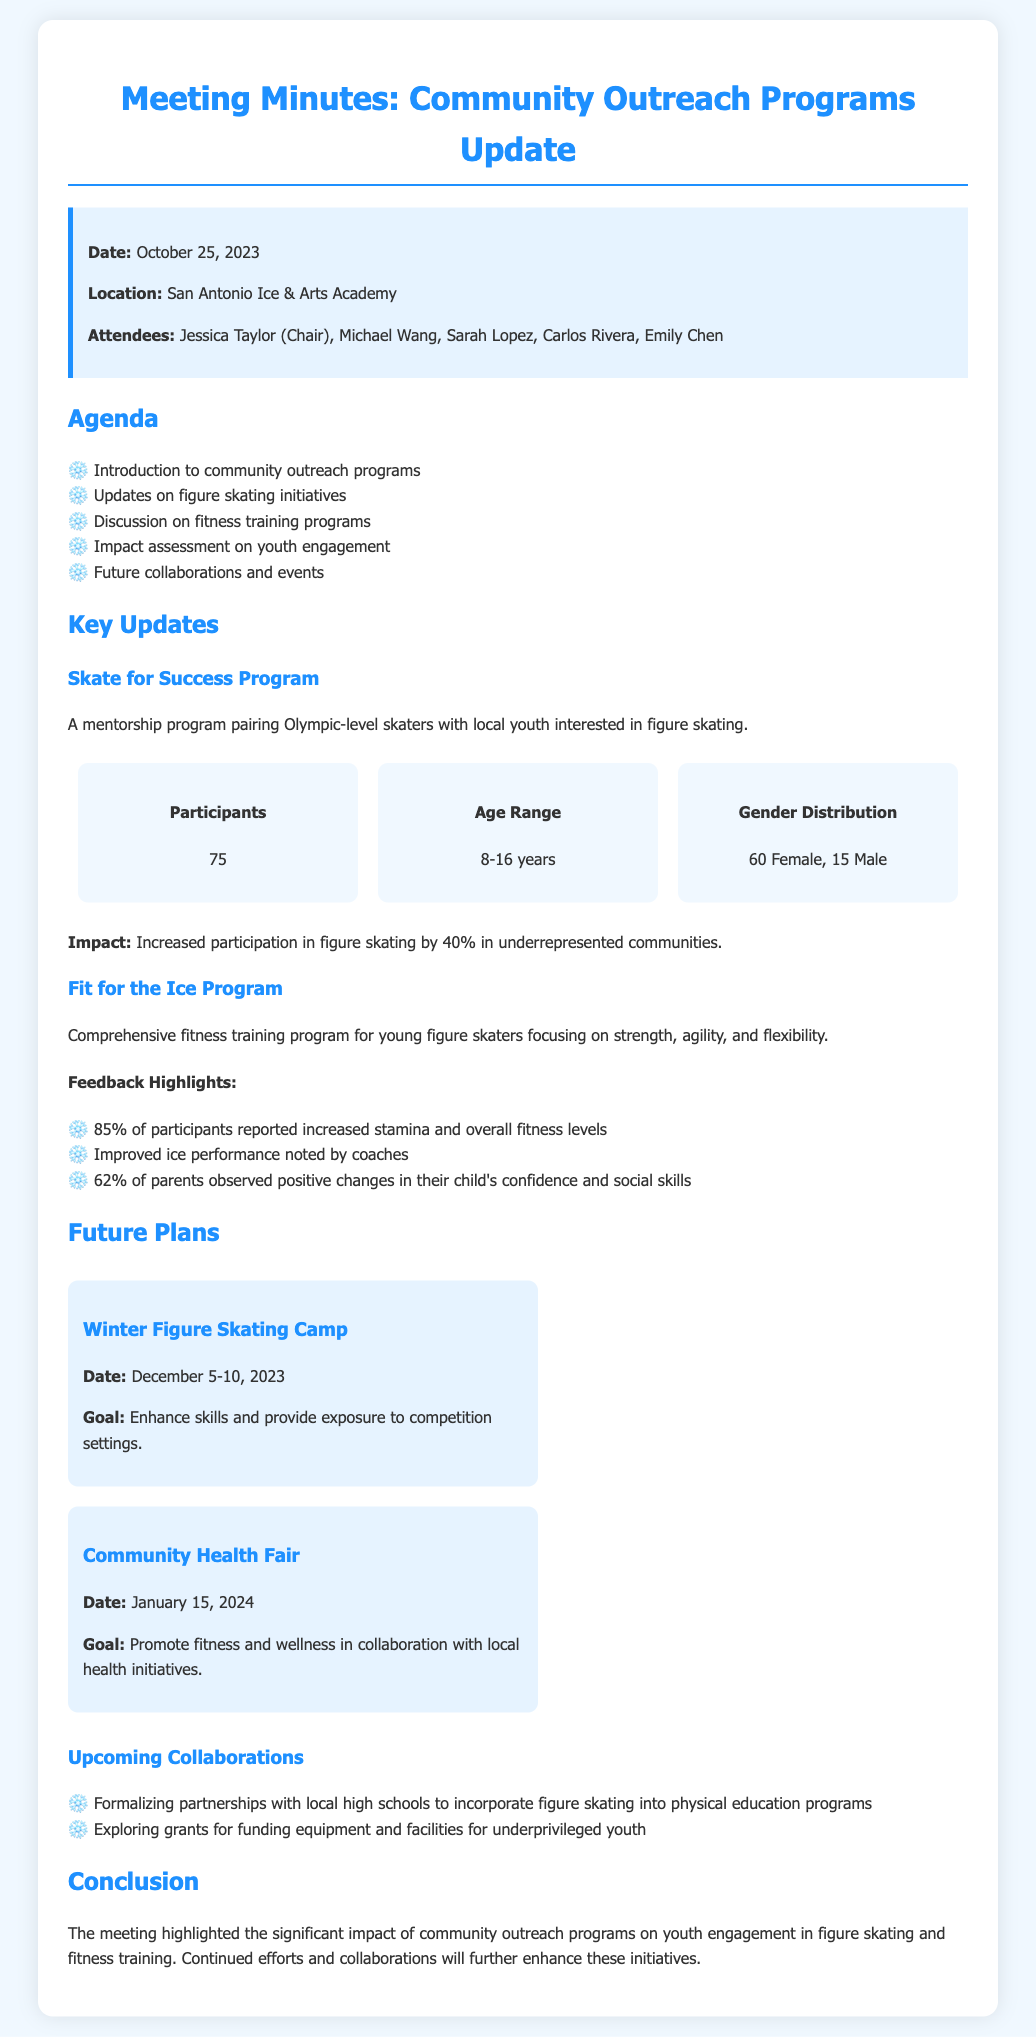what date was the meeting held? The meeting was held on October 25, 2023.
Answer: October 25, 2023 how many participants are involved in the Skate for Success Program? The document states that there are 75 participants in the Skate for Success Program.
Answer: 75 what is the age range of participants in the Skate for Success Program? The age range of participants is mentioned as 8-16 years.
Answer: 8-16 years what percentage of participants reported increased stamina in the Fit for the Ice Program? The document indicates that 85% of participants reported increased stamina.
Answer: 85% what is one goal of the Winter Figure Skating Camp? The goal mentioned for the Winter Figure Skating Camp is to enhance skills and provide exposure to competition settings.
Answer: Enhance skills and provide exposure to competition settings what major collaboration is being explored for funding? The document states that grants are being explored for funding equipment and facilities for underprivileged youth.
Answer: Funding equipment and facilities for underprivileged youth how many female participants are in the Skate for Success Program? The Skate for Success Program has 60 female participants as per the document.
Answer: 60 who chaired the meeting? The meeting was chaired by Jessica Taylor.
Answer: Jessica Taylor 